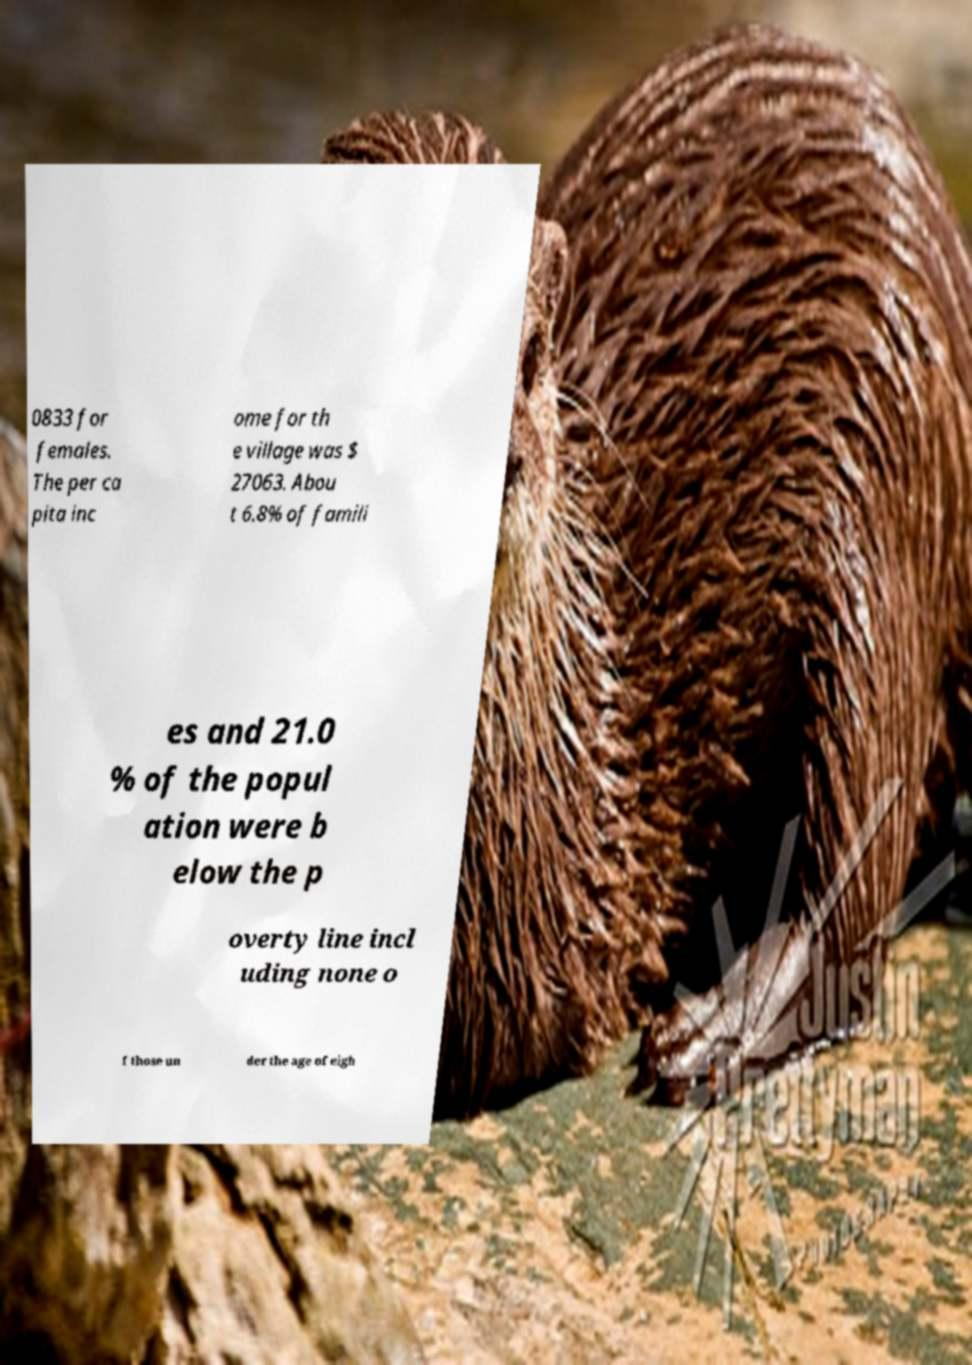What messages or text are displayed in this image? I need them in a readable, typed format. 0833 for females. The per ca pita inc ome for th e village was $ 27063. Abou t 6.8% of famili es and 21.0 % of the popul ation were b elow the p overty line incl uding none o f those un der the age of eigh 